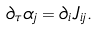<formula> <loc_0><loc_0><loc_500><loc_500>\partial _ { \tau } \alpha _ { j } = \partial _ { i } J _ { i j } .</formula> 